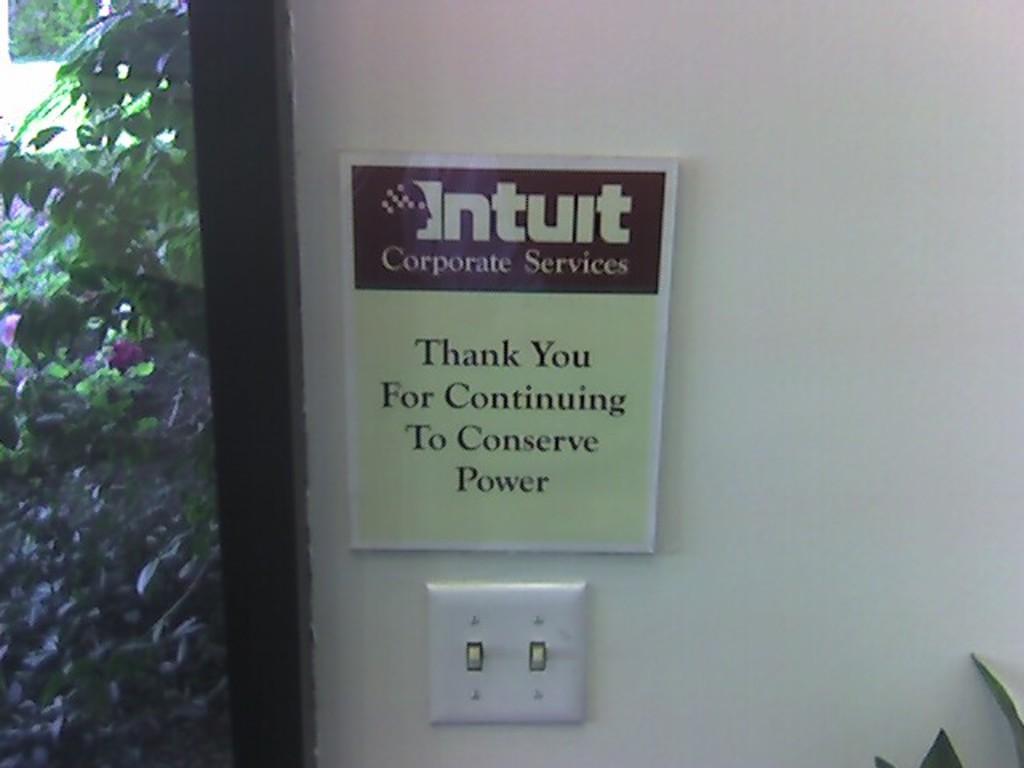Describe this image in one or two sentences. In this image I can see a board attached to the white wall. I can see the glass window and trees. 